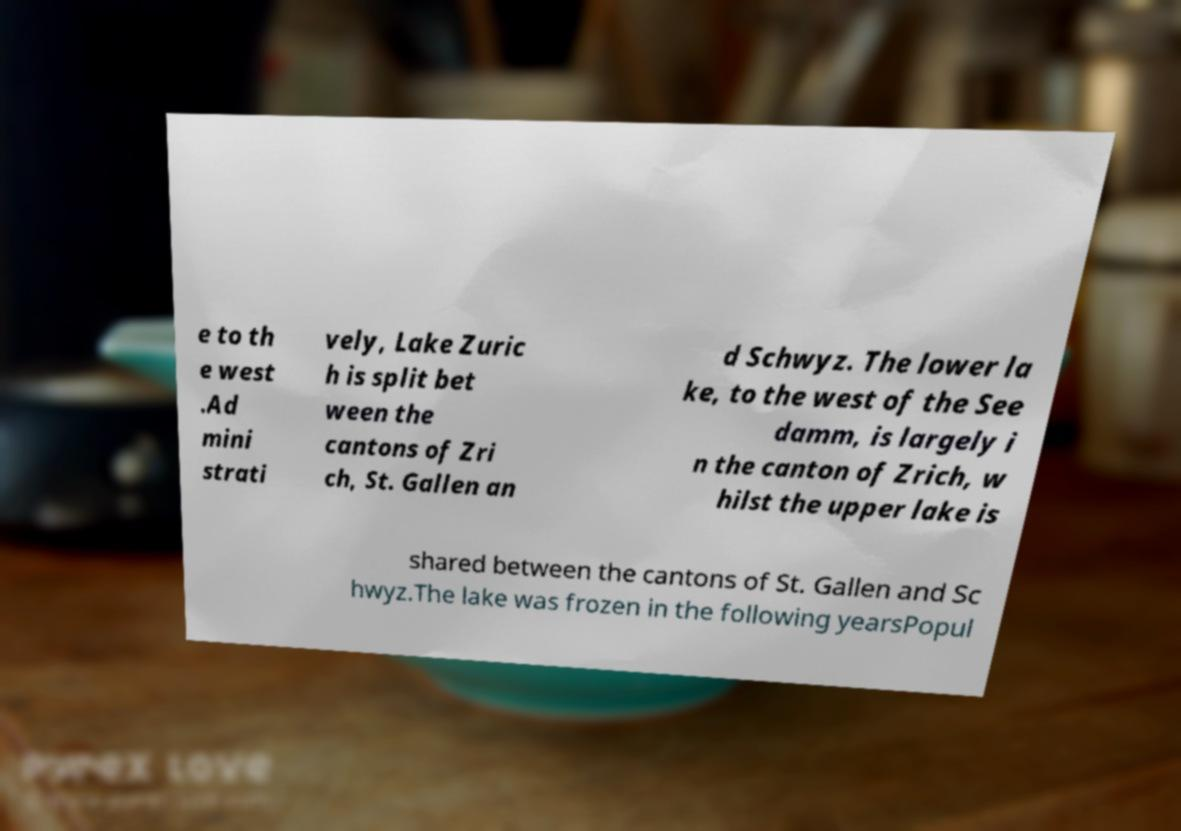Could you extract and type out the text from this image? e to th e west .Ad mini strati vely, Lake Zuric h is split bet ween the cantons of Zri ch, St. Gallen an d Schwyz. The lower la ke, to the west of the See damm, is largely i n the canton of Zrich, w hilst the upper lake is shared between the cantons of St. Gallen and Sc hwyz.The lake was frozen in the following yearsPopul 